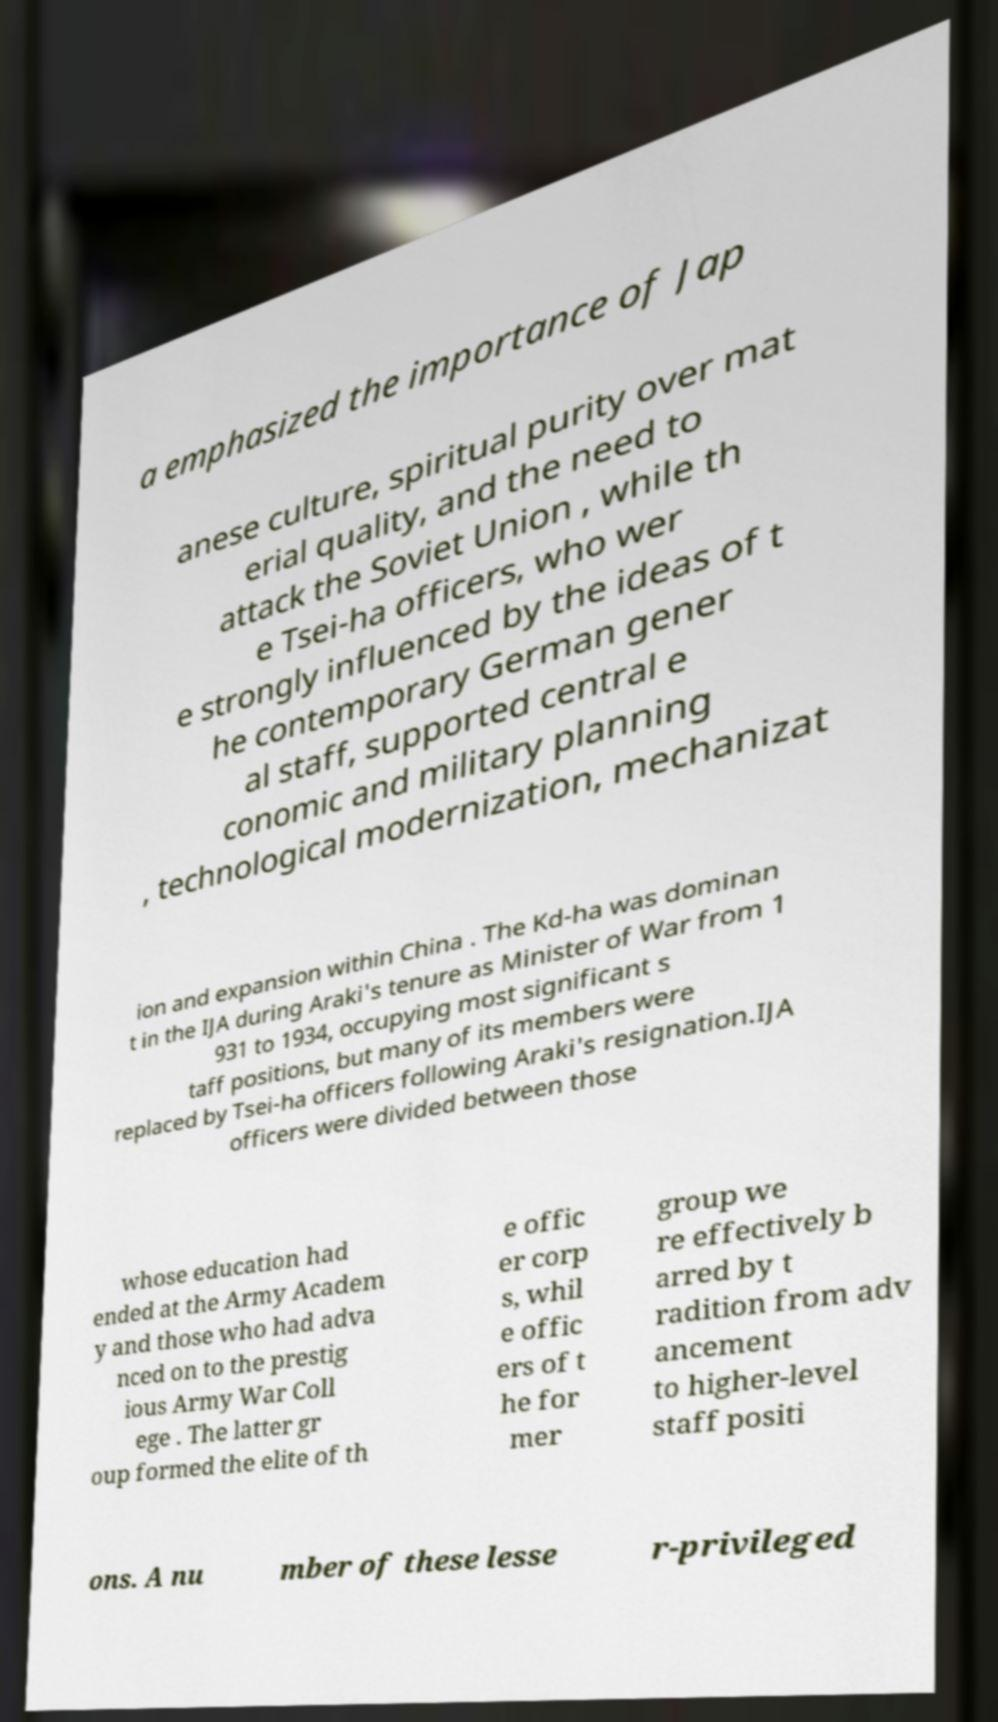Can you accurately transcribe the text from the provided image for me? a emphasized the importance of Jap anese culture, spiritual purity over mat erial quality, and the need to attack the Soviet Union , while th e Tsei-ha officers, who wer e strongly influenced by the ideas of t he contemporary German gener al staff, supported central e conomic and military planning , technological modernization, mechanizat ion and expansion within China . The Kd-ha was dominan t in the IJA during Araki's tenure as Minister of War from 1 931 to 1934, occupying most significant s taff positions, but many of its members were replaced by Tsei-ha officers following Araki's resignation.IJA officers were divided between those whose education had ended at the Army Academ y and those who had adva nced on to the prestig ious Army War Coll ege . The latter gr oup formed the elite of th e offic er corp s, whil e offic ers of t he for mer group we re effectively b arred by t radition from adv ancement to higher-level staff positi ons. A nu mber of these lesse r-privileged 